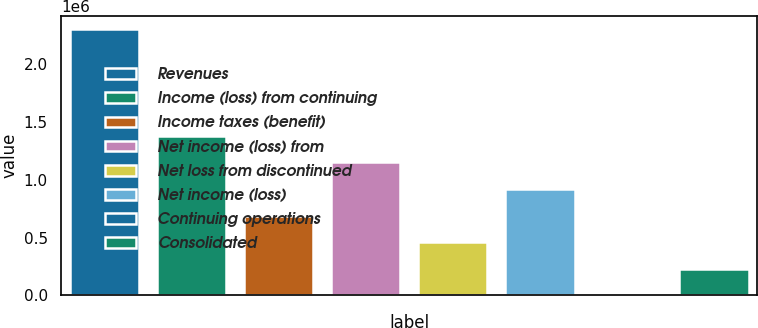<chart> <loc_0><loc_0><loc_500><loc_500><bar_chart><fcel>Revenues<fcel>Income (loss) from continuing<fcel>Income taxes (benefit)<fcel>Net income (loss) from<fcel>Net loss from discontinued<fcel>Net income (loss)<fcel>Continuing operations<fcel>Consolidated<nl><fcel>2.29748e+06<fcel>1.37849e+06<fcel>689245<fcel>1.14874e+06<fcel>459498<fcel>918993<fcel>3.15<fcel>229751<nl></chart> 